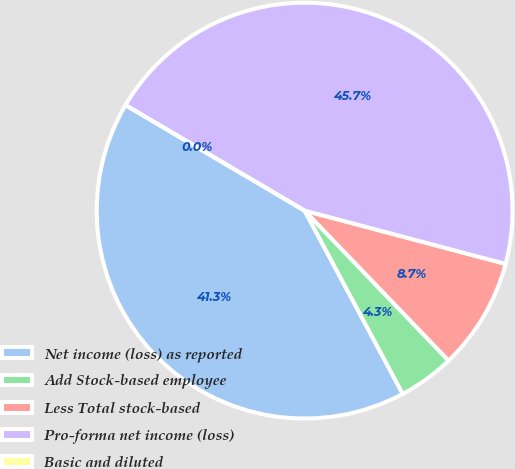<chart> <loc_0><loc_0><loc_500><loc_500><pie_chart><fcel>Net income (loss) as reported<fcel>Add Stock-based employee<fcel>Less Total stock-based<fcel>Pro-forma net income (loss)<fcel>Basic and diluted<nl><fcel>41.3%<fcel>4.35%<fcel>8.7%<fcel>45.65%<fcel>0.0%<nl></chart> 